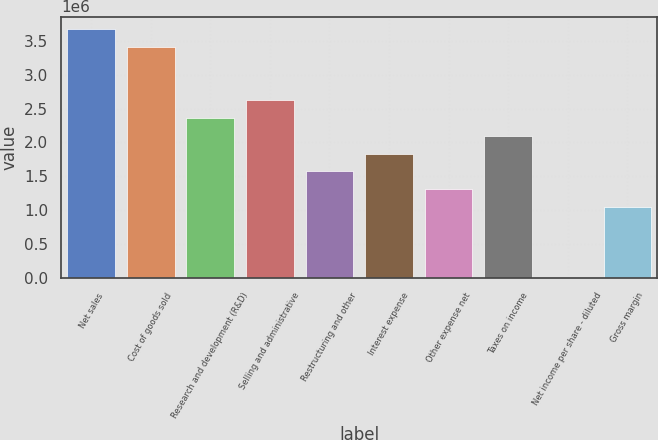<chart> <loc_0><loc_0><loc_500><loc_500><bar_chart><fcel>Net sales<fcel>Cost of goods sold<fcel>Research and development (R&D)<fcel>Selling and administrative<fcel>Restructuring and other<fcel>Interest expense<fcel>Other expense net<fcel>Taxes on income<fcel>Net income per share - diluted<fcel>Gross margin<nl><fcel>3.67201e+06<fcel>3.40972e+06<fcel>2.36058e+06<fcel>2.62286e+06<fcel>1.57372e+06<fcel>1.836e+06<fcel>1.31143e+06<fcel>2.09829e+06<fcel>3.26<fcel>1.04915e+06<nl></chart> 